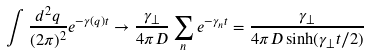<formula> <loc_0><loc_0><loc_500><loc_500>\int \frac { d ^ { 2 } q } { ( 2 \pi ) ^ { 2 } } e ^ { - \gamma ( q ) t } \to \frac { \gamma _ { \perp } } { 4 \pi D } \sum _ { n } e ^ { - \gamma _ { n } t } = \frac { \gamma _ { \perp } } { 4 \pi D \sinh ( \gamma _ { \perp } t / 2 ) }</formula> 